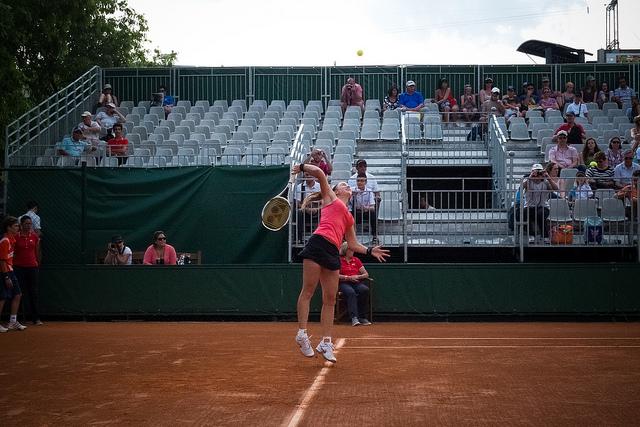What are the seats called that the fans are sitting in?
Concise answer only. Bleachers. Is there a large audience present?
Answer briefly. No. Is the crowd large?
Give a very brief answer. No. What sport is being played?
Keep it brief. Tennis. What is the person holding?
Short answer required. Racket. What sport is this?
Keep it brief. Tennis. Do the lady's feet touch the ground?
Short answer required. No. 